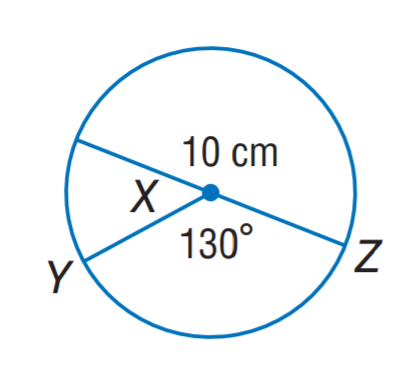Question: Find the length of \widehat Z Y. Round to the nearest hundredth.
Choices:
A. 10.23
B. 11.34
C. 12.67
D. 15.16
Answer with the letter. Answer: B 